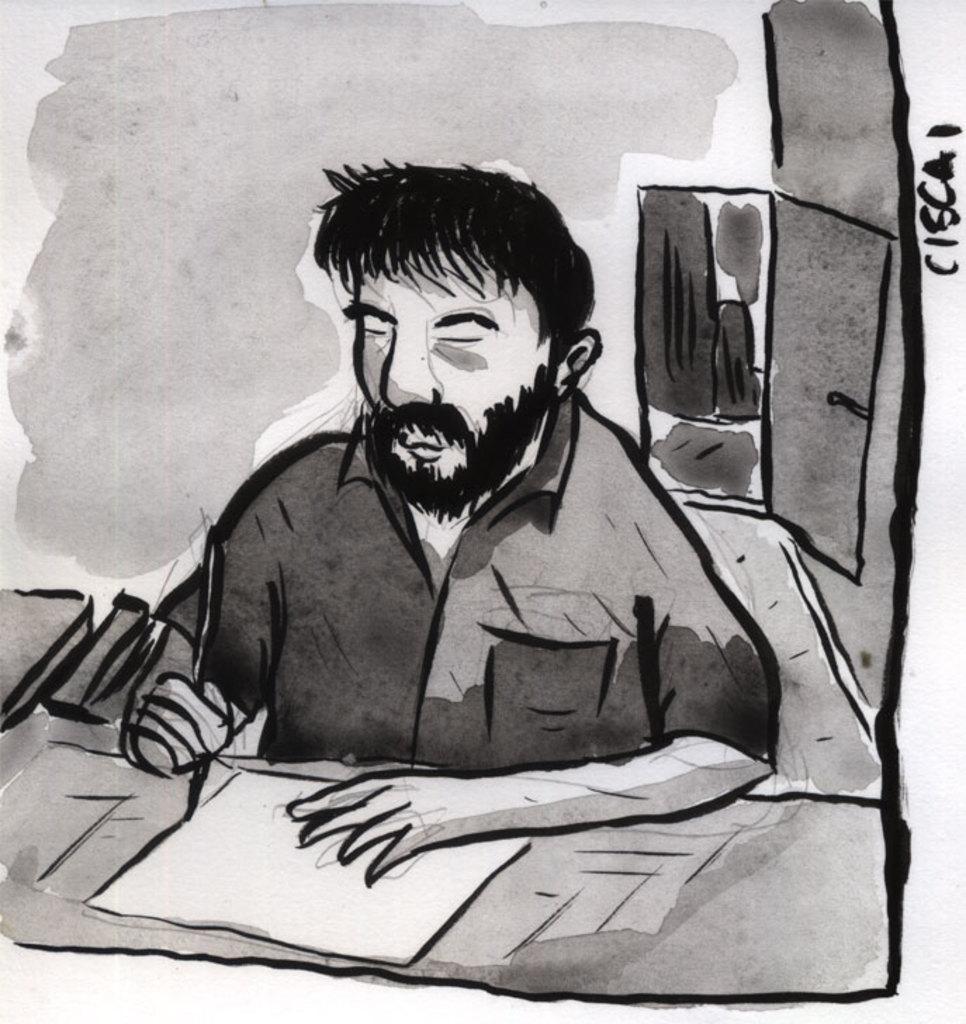Can you describe this image briefly? In this image we can see a painting. In the painting we can see a person. In front of the person we have a paper on a surface. Behind the person we can see a door. On the right side, we can see a wall and text. 